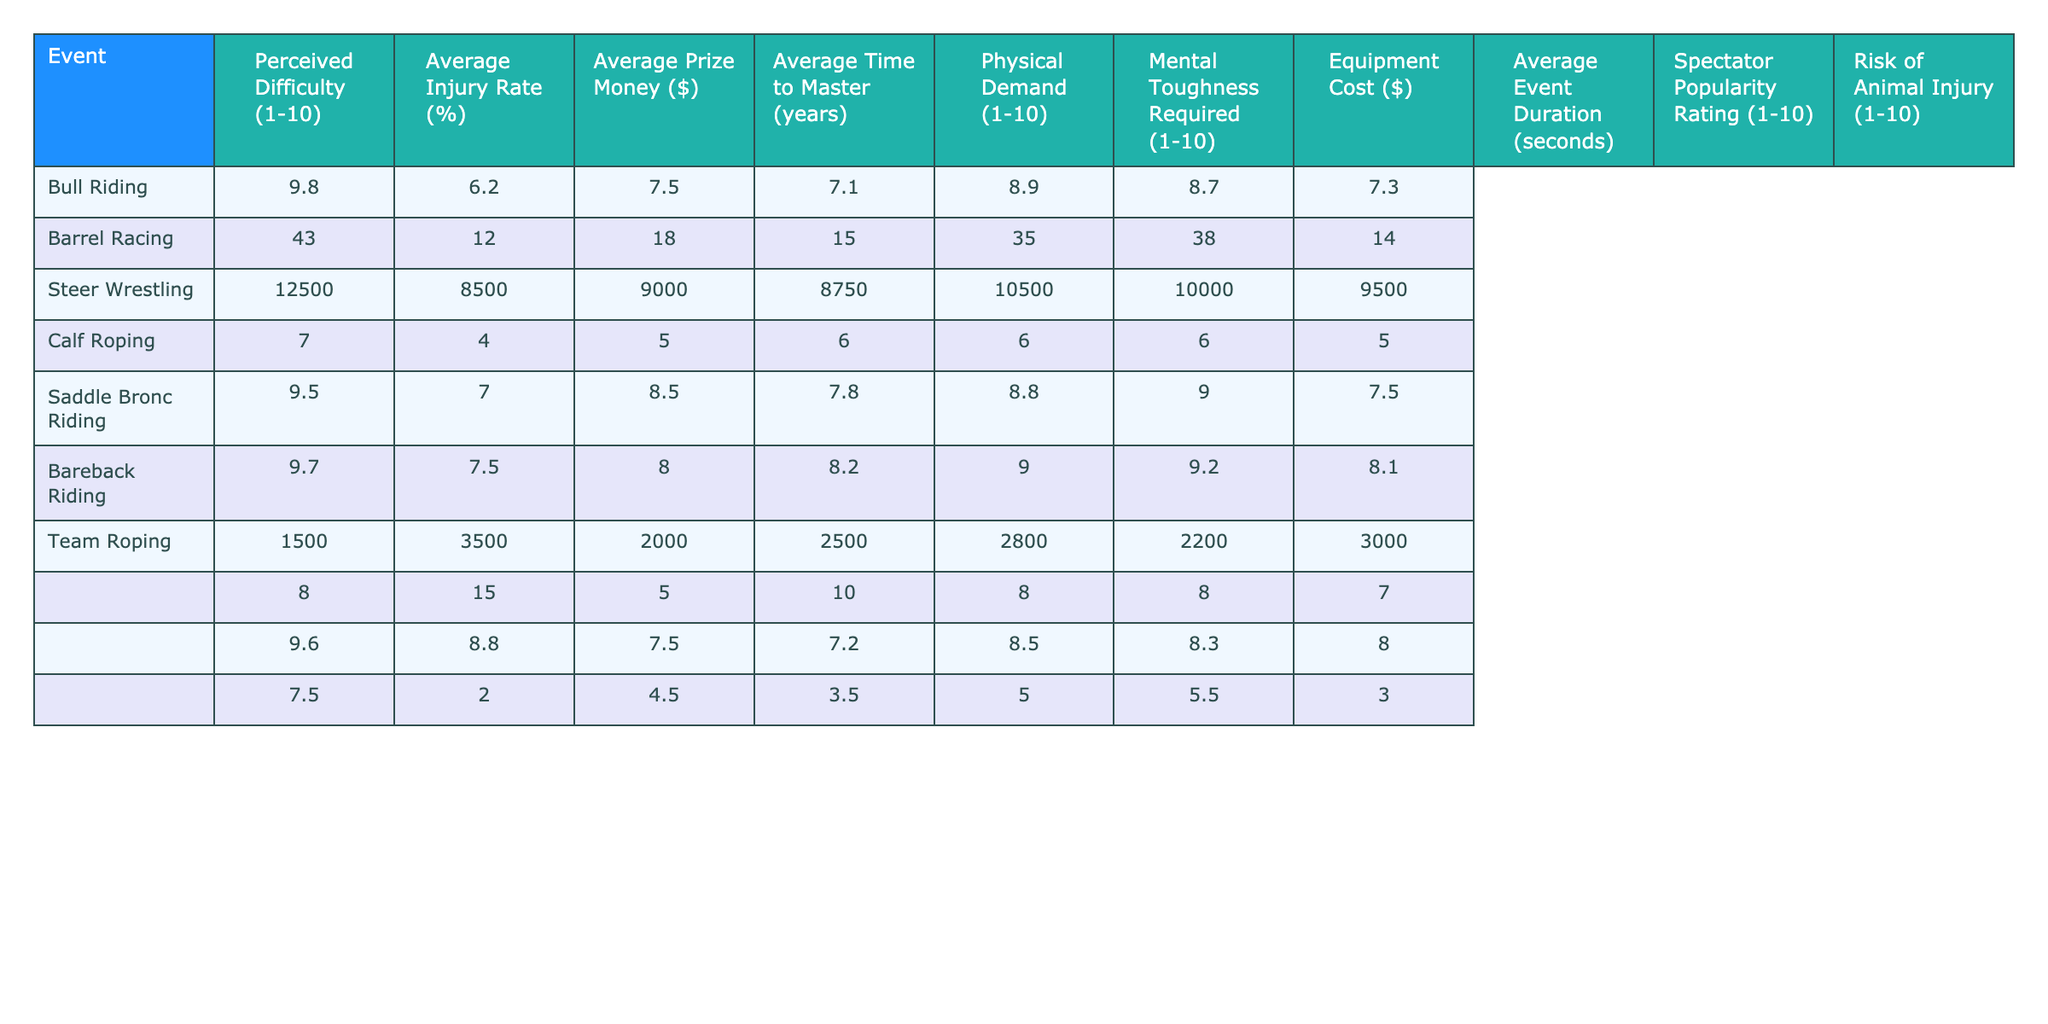What is the perceived difficulty rating for bull riding? The table lists the perceived difficulty for bull riding as 9.8.
Answer: 9.8 Which event has the highest average injury rate? Bull riding has the highest average injury rate at 43%, compared to other events.
Answer: Bull riding What is the average prize money for barrel racing? The table shows that the average prize money for barrel racing is $8,500.
Answer: $8,500 How does the average injury rate of barrel racing compare to calf roping? Barrel racing has an average injury rate of 12%, while calf roping has 15%. Since 12 is less than 15, barrel racing has a lower injury rate.
Answer: Lower What is the average time to master bull riding compared to saddle bronc riding? Bull riding requires an average time to master of 7 years, while saddle bronc riding takes 6 years. Thus, bull riding takes longer to master.
Answer: Longer Which rodeo event requires the most mental toughness? Bull riding has a mental toughness rating of 9.7, which is the highest among all events listed.
Answer: Bull riding What is the difference in average prize money between team roping and calf roping? The average prize money for team roping is $9,500, and for calf roping, it's $8,750. The difference is $9,500 - $8,750 = $750.
Answer: $750 Which rodeo event has the lowest physical demand rating? The physical demand rating for barrel racing is 7.0, which is the lowest compared to other events.
Answer: Barrel racing How does the spectator popularity rating for steer wrestling compare to bareback riding? Steer wrestling has a spectator popularity rating of 7.5, while bareback riding has 8.3. Since 7.5 is less than 8.3, steer wrestling is less popular among spectators.
Answer: Less popular What is the average duration of barrel racing in seconds? The table states that the average event duration for barrel racing is 15 seconds.
Answer: 15 seconds Which event requires more equipment cost: bareback riding or calf roping? The equipment cost for bareback riding is $2,200, while for calf roping it’s $2,500; thus, calf roping requires more equipment cost.
Answer: Calf roping What is the overall average injury rate across all events? First, add up the injury rates: 43 + 12 + 18 + 15 + 35 + 38 + 14 = 175. Then, divide by 7 (the number of events): 175 / 7 = 25. Therefore, the overall average injury rate is 25%.
Answer: 25% Which event has a higher perceived difficulty: saddle bronc riding or steer wrestling? Saddle bronc riding has a perceived difficulty rating of 8.9, which is higher than the 7.5 for steer wrestling.
Answer: Saddle bronc riding What is the highest average prize money among the listed events? The average prize money for bull riding is $12,500, which is higher than that of any other event.
Answer: Bull riding 